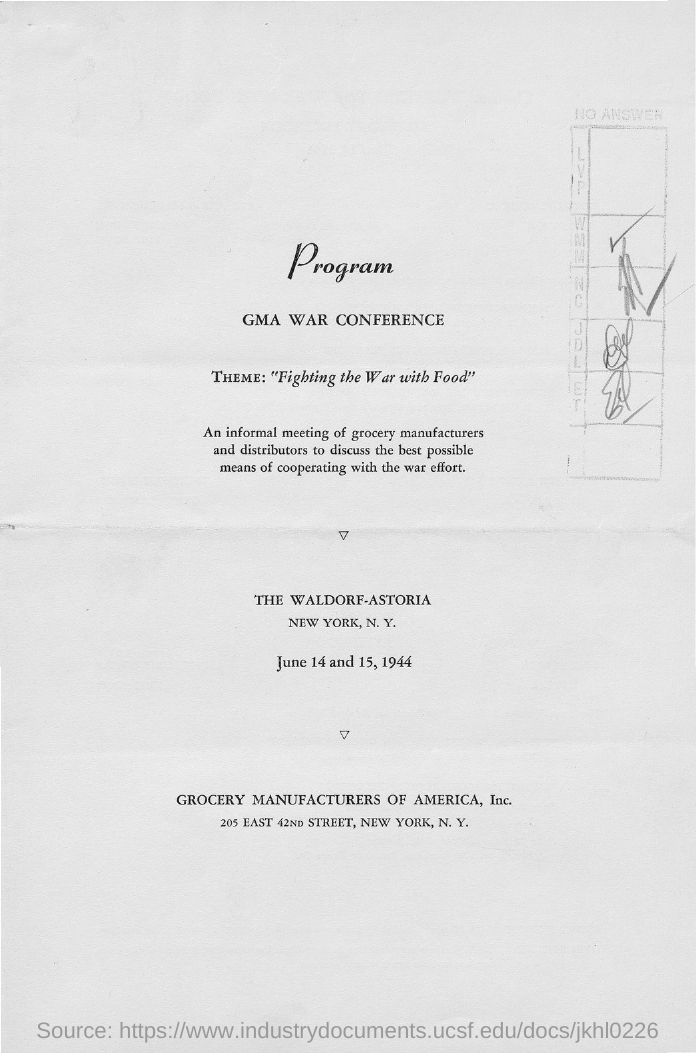Which is the Conference?
Your answer should be very brief. GMA War Conference. What is the theme of the conference?
Your response must be concise. Fighting the war with food. When is the conference?
Make the answer very short. June 14 and 15, 1944. 